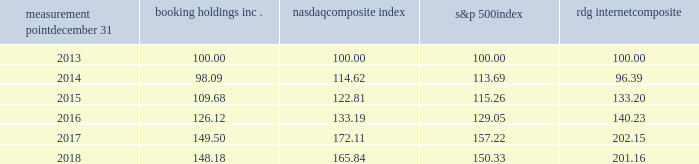Measurement point december 31 booking holdings nasdaq composite index s&p 500 rdg internet composite .

What was the difference in percentage change in booking holding inc . and nasdaq composite index for the five years ended 2018? 
Computations: (((148.18 - 100) / 100) - ((165.84 - 100) / 100))
Answer: -0.1766. 